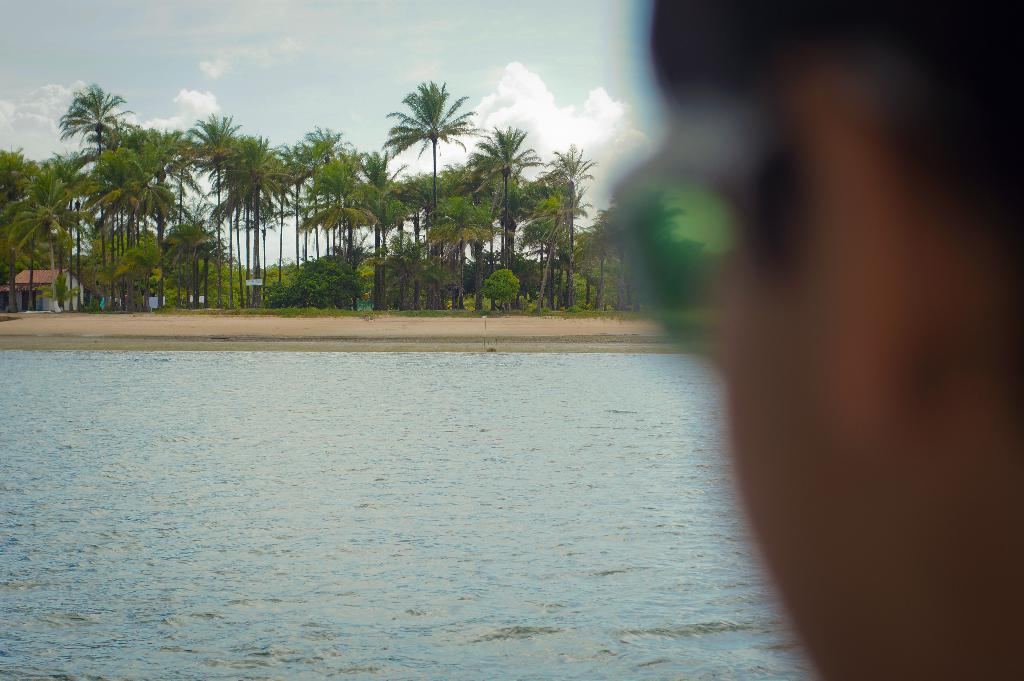What type of vegetation can be seen in the image? There are trees in the image. What type of structure is visible in the image? There is a house in the image. What type of terrain is visible in the image? There is land visible in the image. What type of water body is present in the image? There is water in the image. What is visible at the top of the image? The sky is visible at the top of the image. What can be seen in the sky? Clouds are present in the sky. Where is the person located in the image? There is a person on the right side of the image. What type of current is flowing through the water in the image? There is no mention of a current in the image, as it only shows trees, a house, land, water, the sky, clouds, and a person. How does the presence of clouds in the sky affect the person in the image? The presence of clouds in the sky does not have a direct effect on the person in the image, as they are separate elements in the scene. 